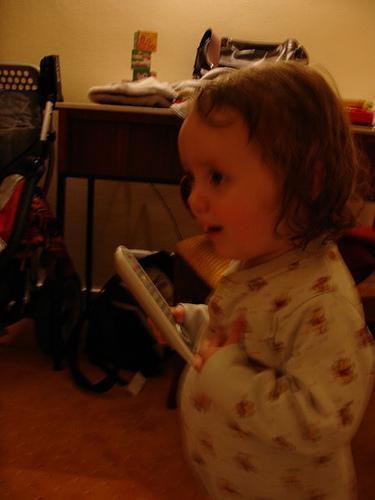Judging by the childs hair what did they just get done with?
Select the correct answer and articulate reasoning with the following format: 'Answer: answer
Rationale: rationale.'
Options: Sleeping, bath, eating, fighting. Answer: bath.
Rationale: The child's hair is slightly wet and looks like she is drying off from a bath. 